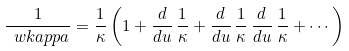Convert formula to latex. <formula><loc_0><loc_0><loc_500><loc_500>\frac { 1 } { \ w k a p p a } = \frac { 1 } { \kappa } \left ( 1 + \frac { d } { d u } \, \frac { 1 } { \kappa } + \frac { d } { d u } \, \frac { 1 } { \kappa } \, \frac { d } { d u } \, \frac { 1 } { \kappa } + \cdots \right )</formula> 